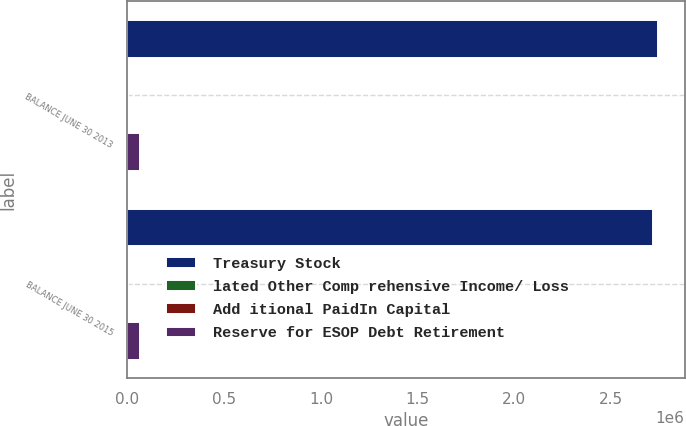<chart> <loc_0><loc_0><loc_500><loc_500><stacked_bar_chart><ecel><fcel>BALANCE JUNE 30 2013<fcel>BALANCE JUNE 30 2015<nl><fcel>Treasury Stock<fcel>2.74233e+06<fcel>2.71457e+06<nl><fcel>lated Other Comp rehensive Income/ Loss<fcel>4009<fcel>4009<nl><fcel>Add itional PaidIn Capital<fcel>1137<fcel>1077<nl><fcel>Reserve for ESOP Debt Retirement<fcel>63538<fcel>63852<nl></chart> 